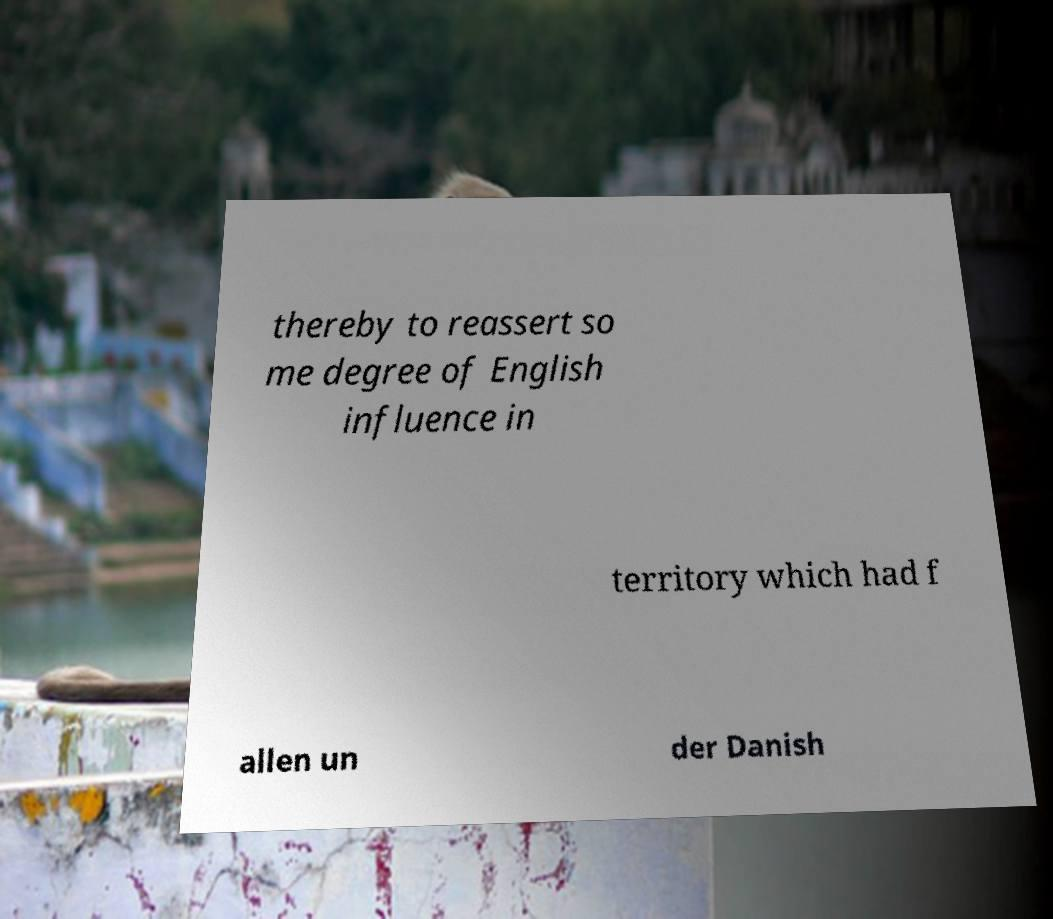Could you extract and type out the text from this image? thereby to reassert so me degree of English influence in territory which had f allen un der Danish 